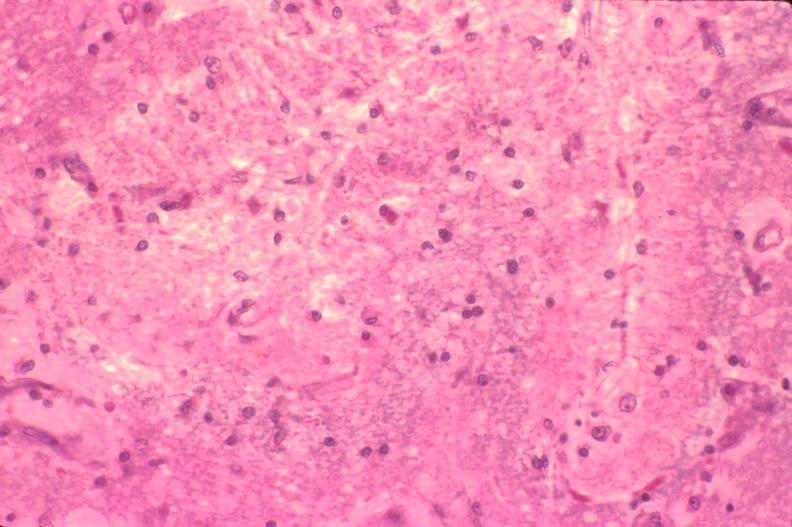s nervous present?
Answer the question using a single word or phrase. Yes 